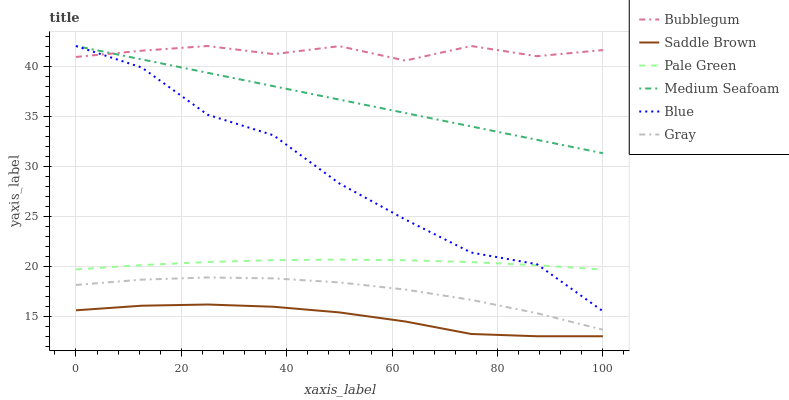Does Saddle Brown have the minimum area under the curve?
Answer yes or no. Yes. Does Bubblegum have the maximum area under the curve?
Answer yes or no. Yes. Does Gray have the minimum area under the curve?
Answer yes or no. No. Does Gray have the maximum area under the curve?
Answer yes or no. No. Is Medium Seafoam the smoothest?
Answer yes or no. Yes. Is Blue the roughest?
Answer yes or no. Yes. Is Gray the smoothest?
Answer yes or no. No. Is Gray the roughest?
Answer yes or no. No. Does Saddle Brown have the lowest value?
Answer yes or no. Yes. Does Gray have the lowest value?
Answer yes or no. No. Does Medium Seafoam have the highest value?
Answer yes or no. Yes. Does Gray have the highest value?
Answer yes or no. No. Is Gray less than Medium Seafoam?
Answer yes or no. Yes. Is Blue greater than Gray?
Answer yes or no. Yes. Does Bubblegum intersect Medium Seafoam?
Answer yes or no. Yes. Is Bubblegum less than Medium Seafoam?
Answer yes or no. No. Is Bubblegum greater than Medium Seafoam?
Answer yes or no. No. Does Gray intersect Medium Seafoam?
Answer yes or no. No. 